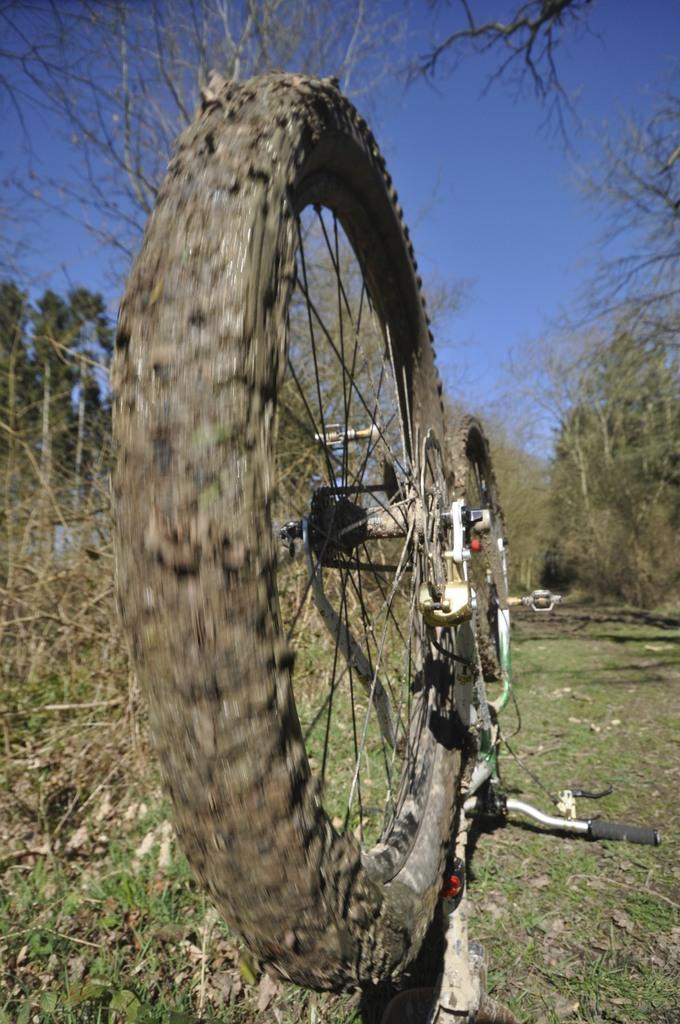What object is on the ground in the image? There is a bicycle on the ground in the image. What can be seen in the background of the image? There are many trees in the background of the image. What is visible at the top of the image? The sky is visible at the top of the image. Where is the library located in the image? There is no library present in the image. Can you describe the harbor in the image? There is no harbor present in the image. 